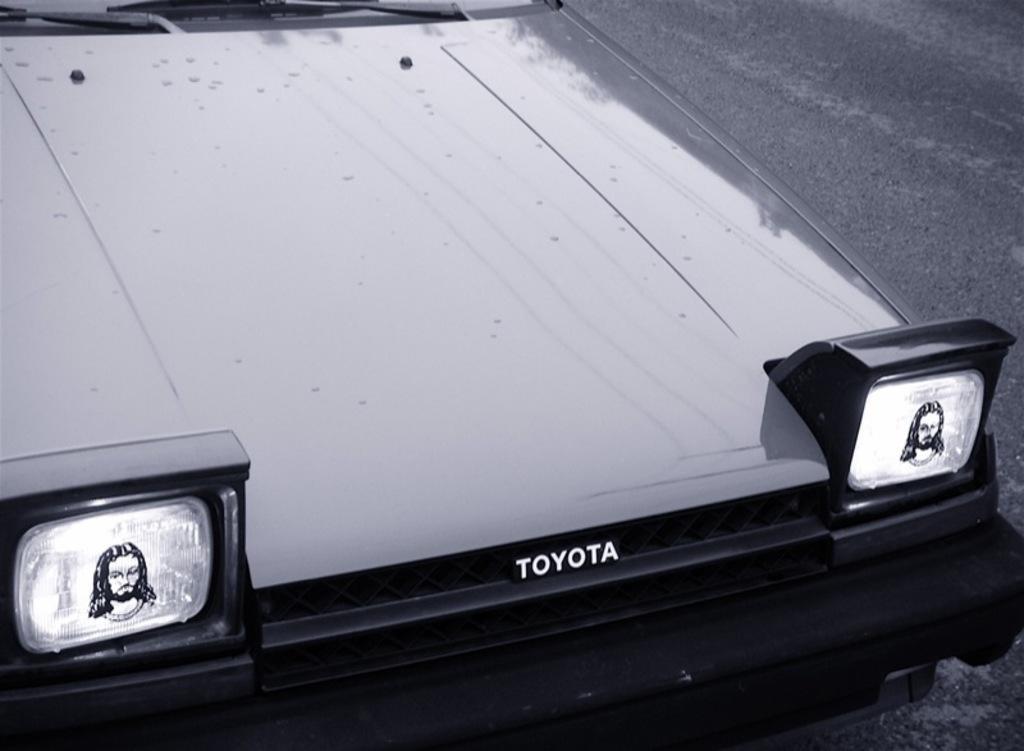How would you summarize this image in a sentence or two? Here in this picture we can see a car present on the road over there and in the front we can see two head lights with sticker of Jesus on it over there. 